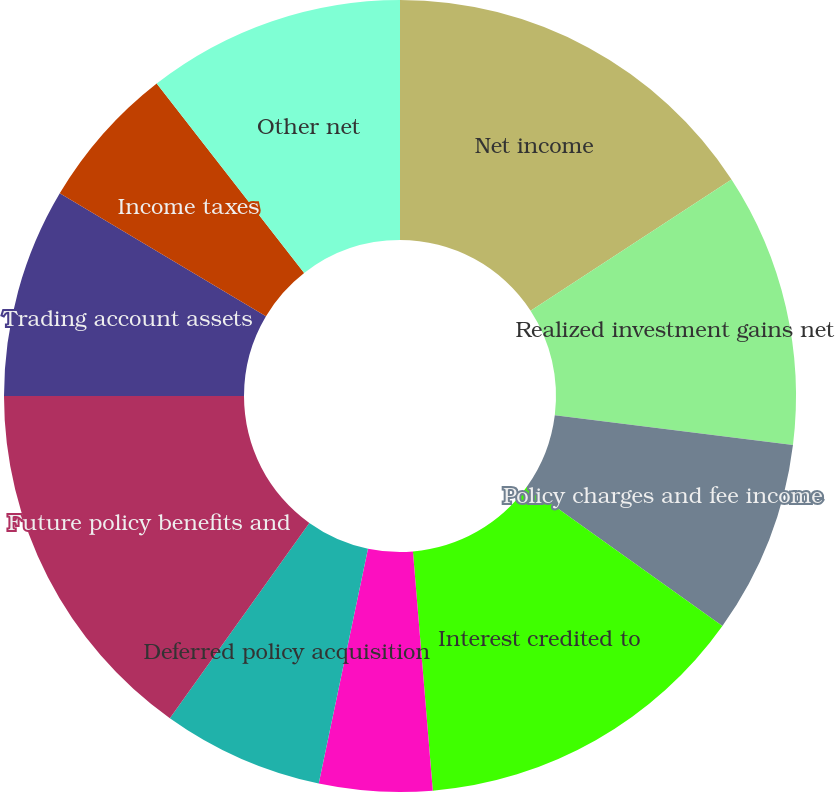<chart> <loc_0><loc_0><loc_500><loc_500><pie_chart><fcel>Net income<fcel>Realized investment gains net<fcel>Policy charges and fee income<fcel>Interest credited to<fcel>Depreciation and amortization<fcel>Deferred policy acquisition<fcel>Future policy benefits and<fcel>Trading account assets<fcel>Income taxes<fcel>Other net<nl><fcel>15.79%<fcel>11.18%<fcel>7.89%<fcel>13.82%<fcel>4.61%<fcel>6.58%<fcel>15.13%<fcel>8.55%<fcel>5.92%<fcel>10.53%<nl></chart> 